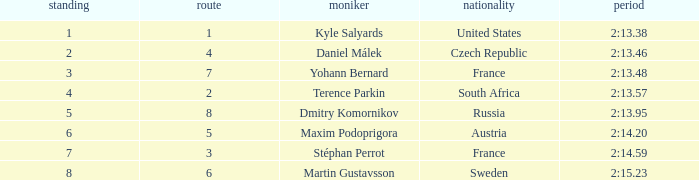What was Maxim Podoprigora's lowest rank? 6.0. 